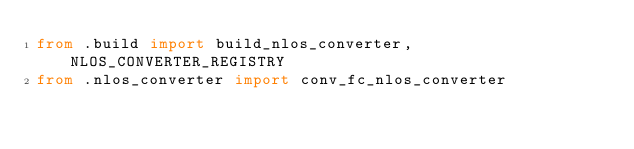Convert code to text. <code><loc_0><loc_0><loc_500><loc_500><_Python_>from .build import build_nlos_converter, NLOS_CONVERTER_REGISTRY
from .nlos_converter import conv_fc_nlos_converter
</code> 